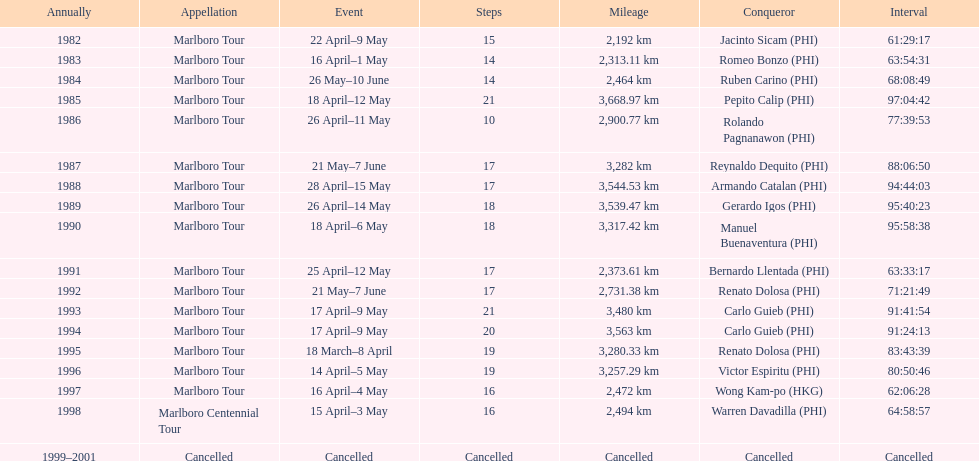Who won the most marlboro tours? Carlo Guieb. 